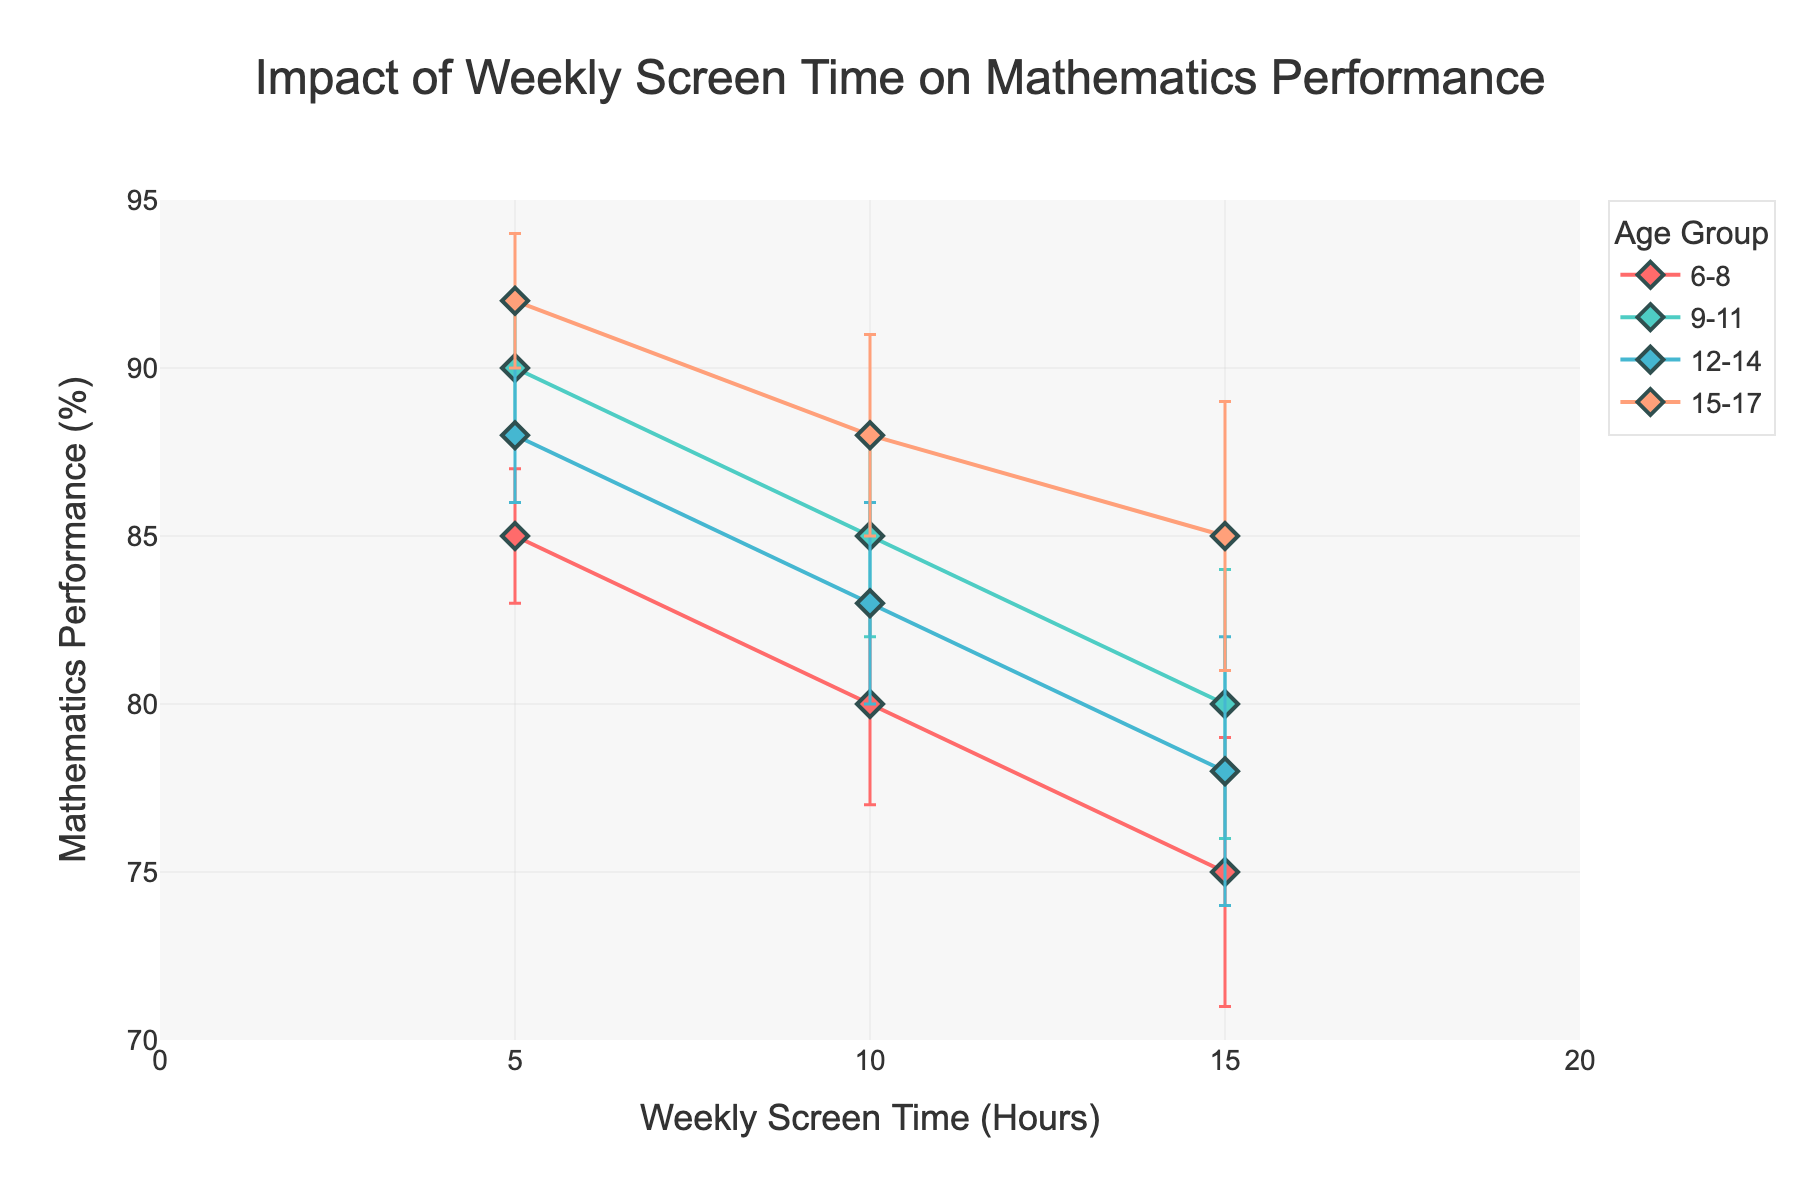What is the title of the figure? The title of the figure is written at the top center of the plot. It is "Impact of Weekly Screen Time on Mathematics Performance".
Answer: Impact of Weekly Screen Time on Mathematics Performance What is the range of the x-axis? The range of the x-axis represents Weekly Screen Time (Hours). From visual inspection, it ranges from 0 to 20 hours.
Answer: 0 to 20 How does mathematics performance change for the 6-8 age group as weekly screen time increases from 5 to 15 hours? For the 6-8 age group, as weekly screen time increases from 5 to 15 hours, mathematics performance decreases from 85% to 75%.
Answer: Decreases from 85% to 75% Which age group has the highest mathematics performance at 5 hours of weekly screen time? For 5 hours of weekly screen time, the age group 15-17 has the highest mathematics performance, marked at 92%.
Answer: 15-17 What is the difference in mathematics performance between the age groups 9-11 and 12-14 when the weekly screen time is 10 hours? At 10 hours of weekly screen time, the mathematics performance for 9-11 age group is 85%, and for 12-14 age group it is 83%. The difference is 85% - 83% = 2%.
Answer: 2% Which age group has the least decrease in mathematics performance from 5 hours to 10 hours of weekly screen time? To find this, we compare the decrease for each group: 
- 6-8: 85% to 80% (5%), 
- 9-11: 90% to 85% (5%), 
- 12-14: 88% to 83% (5%), 
- 15-17: 92% to 88% (4%). 
The 15-17 age group has the least decrease of 4%.
Answer: 15-17 What is the average error range for the 9-11 age group across all screen times? The error ranges for the 9-11 age group are 2, 3, and 4. The average is (2 + 3 + 4)/3 = 9/3 = 3.
Answer: 3 What can you infer about the relationship between screen time and mathematics performance across all age groups? Across all age groups, as weekly screen time increases from 5 to 15 hours, mathematics performance consistently decreases. This suggests a negative correlation between screen time and mathematics performance.
Answer: Negative correlation Does the age group 12-14 show a consistent pattern in mathematics performance with respect to weekly screen time? Yes, the age group 12-14 shows a consistent pattern where mathematics performance decreases as weekly screen time increases: 88% -> 83% -> 78%.
Answer: Yes 